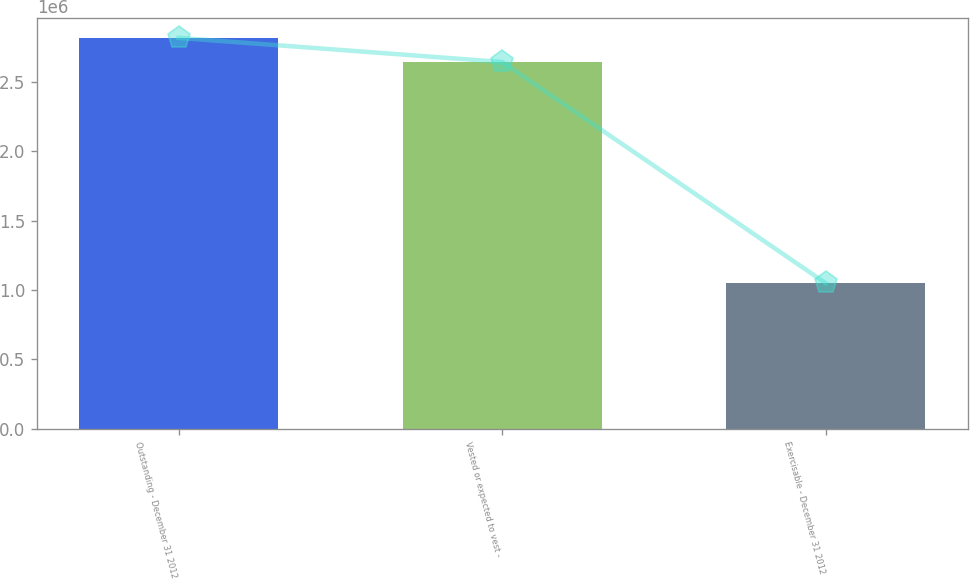Convert chart. <chart><loc_0><loc_0><loc_500><loc_500><bar_chart><fcel>Outstanding - December 31 2012<fcel>Vested or expected to vest -<fcel>Exercisable - December 31 2012<nl><fcel>2.81753e+06<fcel>2.64343e+06<fcel>1.04872e+06<nl></chart> 